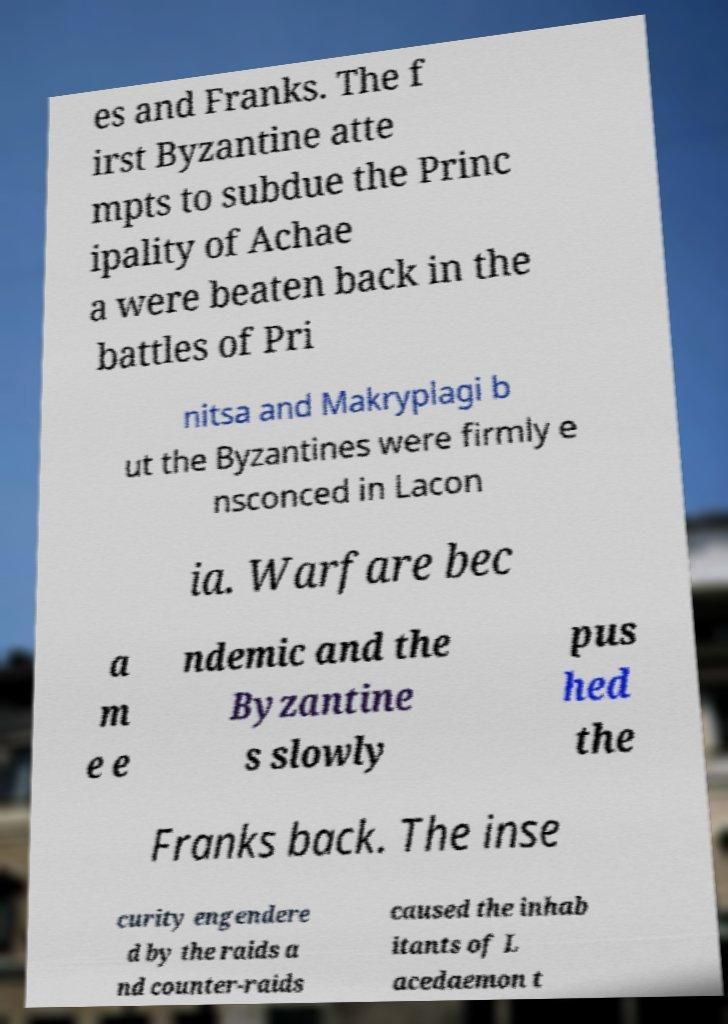Can you read and provide the text displayed in the image?This photo seems to have some interesting text. Can you extract and type it out for me? es and Franks. The f irst Byzantine atte mpts to subdue the Princ ipality of Achae a were beaten back in the battles of Pri nitsa and Makryplagi b ut the Byzantines were firmly e nsconced in Lacon ia. Warfare bec a m e e ndemic and the Byzantine s slowly pus hed the Franks back. The inse curity engendere d by the raids a nd counter-raids caused the inhab itants of L acedaemon t 